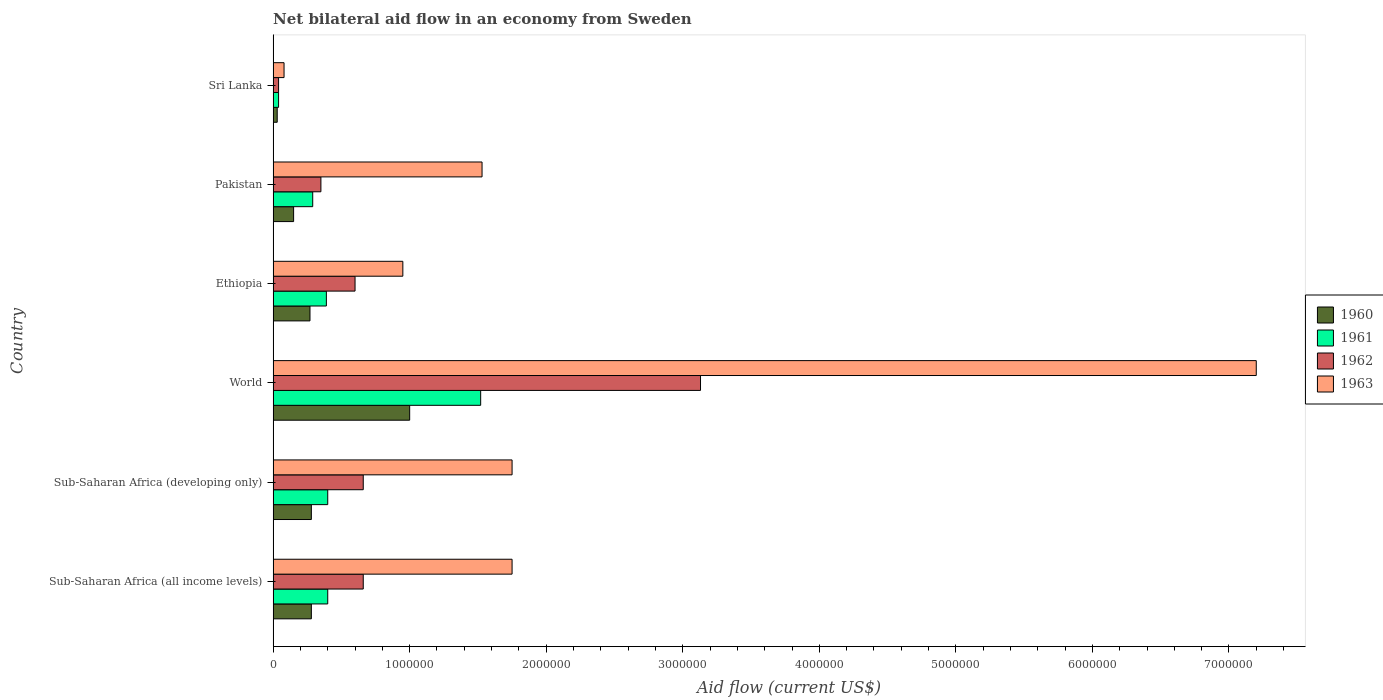Are the number of bars on each tick of the Y-axis equal?
Make the answer very short. Yes. In how many cases, is the number of bars for a given country not equal to the number of legend labels?
Keep it short and to the point. 0. What is the net bilateral aid flow in 1963 in Sub-Saharan Africa (developing only)?
Provide a succinct answer. 1.75e+06. Across all countries, what is the maximum net bilateral aid flow in 1961?
Ensure brevity in your answer.  1.52e+06. Across all countries, what is the minimum net bilateral aid flow in 1963?
Make the answer very short. 8.00e+04. In which country was the net bilateral aid flow in 1963 maximum?
Offer a very short reply. World. In which country was the net bilateral aid flow in 1961 minimum?
Provide a succinct answer. Sri Lanka. What is the total net bilateral aid flow in 1960 in the graph?
Your answer should be compact. 2.01e+06. What is the difference between the net bilateral aid flow in 1963 in Ethiopia and that in Pakistan?
Provide a short and direct response. -5.80e+05. What is the average net bilateral aid flow in 1961 per country?
Your answer should be very brief. 5.07e+05. What is the ratio of the net bilateral aid flow in 1961 in Pakistan to that in Sub-Saharan Africa (developing only)?
Give a very brief answer. 0.72. Is the net bilateral aid flow in 1961 in Sri Lanka less than that in World?
Your response must be concise. Yes. What is the difference between the highest and the second highest net bilateral aid flow in 1960?
Your answer should be very brief. 7.20e+05. What is the difference between the highest and the lowest net bilateral aid flow in 1963?
Your answer should be compact. 7.12e+06. In how many countries, is the net bilateral aid flow in 1962 greater than the average net bilateral aid flow in 1962 taken over all countries?
Provide a short and direct response. 1. Is the sum of the net bilateral aid flow in 1960 in Sub-Saharan Africa (all income levels) and World greater than the maximum net bilateral aid flow in 1961 across all countries?
Provide a succinct answer. No. What does the 1st bar from the bottom in Sub-Saharan Africa (developing only) represents?
Give a very brief answer. 1960. Is it the case that in every country, the sum of the net bilateral aid flow in 1961 and net bilateral aid flow in 1960 is greater than the net bilateral aid flow in 1963?
Provide a succinct answer. No. How many bars are there?
Offer a very short reply. 24. What is the difference between two consecutive major ticks on the X-axis?
Offer a terse response. 1.00e+06. Does the graph contain any zero values?
Make the answer very short. No. How are the legend labels stacked?
Your response must be concise. Vertical. What is the title of the graph?
Give a very brief answer. Net bilateral aid flow in an economy from Sweden. Does "1975" appear as one of the legend labels in the graph?
Keep it short and to the point. No. What is the label or title of the Y-axis?
Your answer should be compact. Country. What is the Aid flow (current US$) of 1962 in Sub-Saharan Africa (all income levels)?
Your answer should be very brief. 6.60e+05. What is the Aid flow (current US$) of 1963 in Sub-Saharan Africa (all income levels)?
Offer a terse response. 1.75e+06. What is the Aid flow (current US$) of 1961 in Sub-Saharan Africa (developing only)?
Provide a succinct answer. 4.00e+05. What is the Aid flow (current US$) of 1962 in Sub-Saharan Africa (developing only)?
Make the answer very short. 6.60e+05. What is the Aid flow (current US$) of 1963 in Sub-Saharan Africa (developing only)?
Your answer should be compact. 1.75e+06. What is the Aid flow (current US$) in 1961 in World?
Offer a very short reply. 1.52e+06. What is the Aid flow (current US$) of 1962 in World?
Your answer should be very brief. 3.13e+06. What is the Aid flow (current US$) of 1963 in World?
Give a very brief answer. 7.20e+06. What is the Aid flow (current US$) in 1960 in Ethiopia?
Your response must be concise. 2.70e+05. What is the Aid flow (current US$) in 1963 in Ethiopia?
Offer a very short reply. 9.50e+05. What is the Aid flow (current US$) of 1962 in Pakistan?
Your answer should be very brief. 3.50e+05. What is the Aid flow (current US$) in 1963 in Pakistan?
Ensure brevity in your answer.  1.53e+06. What is the Aid flow (current US$) of 1961 in Sri Lanka?
Ensure brevity in your answer.  4.00e+04. What is the Aid flow (current US$) in 1962 in Sri Lanka?
Give a very brief answer. 4.00e+04. What is the Aid flow (current US$) of 1963 in Sri Lanka?
Your response must be concise. 8.00e+04. Across all countries, what is the maximum Aid flow (current US$) of 1960?
Ensure brevity in your answer.  1.00e+06. Across all countries, what is the maximum Aid flow (current US$) in 1961?
Keep it short and to the point. 1.52e+06. Across all countries, what is the maximum Aid flow (current US$) of 1962?
Offer a very short reply. 3.13e+06. Across all countries, what is the maximum Aid flow (current US$) of 1963?
Provide a succinct answer. 7.20e+06. Across all countries, what is the minimum Aid flow (current US$) of 1962?
Provide a succinct answer. 4.00e+04. Across all countries, what is the minimum Aid flow (current US$) of 1963?
Keep it short and to the point. 8.00e+04. What is the total Aid flow (current US$) of 1960 in the graph?
Offer a very short reply. 2.01e+06. What is the total Aid flow (current US$) in 1961 in the graph?
Give a very brief answer. 3.04e+06. What is the total Aid flow (current US$) of 1962 in the graph?
Give a very brief answer. 5.44e+06. What is the total Aid flow (current US$) in 1963 in the graph?
Provide a short and direct response. 1.33e+07. What is the difference between the Aid flow (current US$) of 1962 in Sub-Saharan Africa (all income levels) and that in Sub-Saharan Africa (developing only)?
Offer a terse response. 0. What is the difference between the Aid flow (current US$) in 1963 in Sub-Saharan Africa (all income levels) and that in Sub-Saharan Africa (developing only)?
Your response must be concise. 0. What is the difference between the Aid flow (current US$) in 1960 in Sub-Saharan Africa (all income levels) and that in World?
Offer a terse response. -7.20e+05. What is the difference between the Aid flow (current US$) in 1961 in Sub-Saharan Africa (all income levels) and that in World?
Your response must be concise. -1.12e+06. What is the difference between the Aid flow (current US$) in 1962 in Sub-Saharan Africa (all income levels) and that in World?
Make the answer very short. -2.47e+06. What is the difference between the Aid flow (current US$) in 1963 in Sub-Saharan Africa (all income levels) and that in World?
Keep it short and to the point. -5.45e+06. What is the difference between the Aid flow (current US$) in 1962 in Sub-Saharan Africa (all income levels) and that in Ethiopia?
Make the answer very short. 6.00e+04. What is the difference between the Aid flow (current US$) of 1963 in Sub-Saharan Africa (all income levels) and that in Ethiopia?
Your answer should be compact. 8.00e+05. What is the difference between the Aid flow (current US$) in 1960 in Sub-Saharan Africa (all income levels) and that in Sri Lanka?
Your answer should be compact. 2.50e+05. What is the difference between the Aid flow (current US$) in 1962 in Sub-Saharan Africa (all income levels) and that in Sri Lanka?
Your response must be concise. 6.20e+05. What is the difference between the Aid flow (current US$) of 1963 in Sub-Saharan Africa (all income levels) and that in Sri Lanka?
Give a very brief answer. 1.67e+06. What is the difference between the Aid flow (current US$) in 1960 in Sub-Saharan Africa (developing only) and that in World?
Your answer should be very brief. -7.20e+05. What is the difference between the Aid flow (current US$) in 1961 in Sub-Saharan Africa (developing only) and that in World?
Ensure brevity in your answer.  -1.12e+06. What is the difference between the Aid flow (current US$) of 1962 in Sub-Saharan Africa (developing only) and that in World?
Offer a very short reply. -2.47e+06. What is the difference between the Aid flow (current US$) in 1963 in Sub-Saharan Africa (developing only) and that in World?
Your answer should be compact. -5.45e+06. What is the difference between the Aid flow (current US$) of 1961 in Sub-Saharan Africa (developing only) and that in Ethiopia?
Ensure brevity in your answer.  10000. What is the difference between the Aid flow (current US$) of 1963 in Sub-Saharan Africa (developing only) and that in Ethiopia?
Offer a terse response. 8.00e+05. What is the difference between the Aid flow (current US$) in 1960 in Sub-Saharan Africa (developing only) and that in Pakistan?
Keep it short and to the point. 1.30e+05. What is the difference between the Aid flow (current US$) in 1961 in Sub-Saharan Africa (developing only) and that in Pakistan?
Give a very brief answer. 1.10e+05. What is the difference between the Aid flow (current US$) of 1963 in Sub-Saharan Africa (developing only) and that in Pakistan?
Your response must be concise. 2.20e+05. What is the difference between the Aid flow (current US$) of 1961 in Sub-Saharan Africa (developing only) and that in Sri Lanka?
Offer a terse response. 3.60e+05. What is the difference between the Aid flow (current US$) of 1962 in Sub-Saharan Africa (developing only) and that in Sri Lanka?
Your answer should be compact. 6.20e+05. What is the difference between the Aid flow (current US$) in 1963 in Sub-Saharan Africa (developing only) and that in Sri Lanka?
Keep it short and to the point. 1.67e+06. What is the difference between the Aid flow (current US$) in 1960 in World and that in Ethiopia?
Provide a short and direct response. 7.30e+05. What is the difference between the Aid flow (current US$) in 1961 in World and that in Ethiopia?
Provide a short and direct response. 1.13e+06. What is the difference between the Aid flow (current US$) in 1962 in World and that in Ethiopia?
Your answer should be compact. 2.53e+06. What is the difference between the Aid flow (current US$) in 1963 in World and that in Ethiopia?
Give a very brief answer. 6.25e+06. What is the difference between the Aid flow (current US$) of 1960 in World and that in Pakistan?
Your response must be concise. 8.50e+05. What is the difference between the Aid flow (current US$) of 1961 in World and that in Pakistan?
Your answer should be very brief. 1.23e+06. What is the difference between the Aid flow (current US$) in 1962 in World and that in Pakistan?
Keep it short and to the point. 2.78e+06. What is the difference between the Aid flow (current US$) in 1963 in World and that in Pakistan?
Make the answer very short. 5.67e+06. What is the difference between the Aid flow (current US$) of 1960 in World and that in Sri Lanka?
Offer a very short reply. 9.70e+05. What is the difference between the Aid flow (current US$) of 1961 in World and that in Sri Lanka?
Offer a terse response. 1.48e+06. What is the difference between the Aid flow (current US$) in 1962 in World and that in Sri Lanka?
Give a very brief answer. 3.09e+06. What is the difference between the Aid flow (current US$) in 1963 in World and that in Sri Lanka?
Keep it short and to the point. 7.12e+06. What is the difference between the Aid flow (current US$) of 1960 in Ethiopia and that in Pakistan?
Your answer should be very brief. 1.20e+05. What is the difference between the Aid flow (current US$) in 1961 in Ethiopia and that in Pakistan?
Offer a terse response. 1.00e+05. What is the difference between the Aid flow (current US$) in 1962 in Ethiopia and that in Pakistan?
Ensure brevity in your answer.  2.50e+05. What is the difference between the Aid flow (current US$) in 1963 in Ethiopia and that in Pakistan?
Offer a terse response. -5.80e+05. What is the difference between the Aid flow (current US$) in 1960 in Ethiopia and that in Sri Lanka?
Offer a very short reply. 2.40e+05. What is the difference between the Aid flow (current US$) of 1962 in Ethiopia and that in Sri Lanka?
Your answer should be compact. 5.60e+05. What is the difference between the Aid flow (current US$) in 1963 in Ethiopia and that in Sri Lanka?
Offer a very short reply. 8.70e+05. What is the difference between the Aid flow (current US$) in 1960 in Pakistan and that in Sri Lanka?
Give a very brief answer. 1.20e+05. What is the difference between the Aid flow (current US$) in 1963 in Pakistan and that in Sri Lanka?
Your response must be concise. 1.45e+06. What is the difference between the Aid flow (current US$) in 1960 in Sub-Saharan Africa (all income levels) and the Aid flow (current US$) in 1961 in Sub-Saharan Africa (developing only)?
Offer a very short reply. -1.20e+05. What is the difference between the Aid flow (current US$) in 1960 in Sub-Saharan Africa (all income levels) and the Aid flow (current US$) in 1962 in Sub-Saharan Africa (developing only)?
Your answer should be very brief. -3.80e+05. What is the difference between the Aid flow (current US$) in 1960 in Sub-Saharan Africa (all income levels) and the Aid flow (current US$) in 1963 in Sub-Saharan Africa (developing only)?
Make the answer very short. -1.47e+06. What is the difference between the Aid flow (current US$) in 1961 in Sub-Saharan Africa (all income levels) and the Aid flow (current US$) in 1962 in Sub-Saharan Africa (developing only)?
Your answer should be very brief. -2.60e+05. What is the difference between the Aid flow (current US$) in 1961 in Sub-Saharan Africa (all income levels) and the Aid flow (current US$) in 1963 in Sub-Saharan Africa (developing only)?
Your answer should be very brief. -1.35e+06. What is the difference between the Aid flow (current US$) of 1962 in Sub-Saharan Africa (all income levels) and the Aid flow (current US$) of 1963 in Sub-Saharan Africa (developing only)?
Offer a very short reply. -1.09e+06. What is the difference between the Aid flow (current US$) of 1960 in Sub-Saharan Africa (all income levels) and the Aid flow (current US$) of 1961 in World?
Ensure brevity in your answer.  -1.24e+06. What is the difference between the Aid flow (current US$) in 1960 in Sub-Saharan Africa (all income levels) and the Aid flow (current US$) in 1962 in World?
Your answer should be very brief. -2.85e+06. What is the difference between the Aid flow (current US$) in 1960 in Sub-Saharan Africa (all income levels) and the Aid flow (current US$) in 1963 in World?
Keep it short and to the point. -6.92e+06. What is the difference between the Aid flow (current US$) in 1961 in Sub-Saharan Africa (all income levels) and the Aid flow (current US$) in 1962 in World?
Your answer should be very brief. -2.73e+06. What is the difference between the Aid flow (current US$) of 1961 in Sub-Saharan Africa (all income levels) and the Aid flow (current US$) of 1963 in World?
Ensure brevity in your answer.  -6.80e+06. What is the difference between the Aid flow (current US$) of 1962 in Sub-Saharan Africa (all income levels) and the Aid flow (current US$) of 1963 in World?
Offer a very short reply. -6.54e+06. What is the difference between the Aid flow (current US$) in 1960 in Sub-Saharan Africa (all income levels) and the Aid flow (current US$) in 1962 in Ethiopia?
Your response must be concise. -3.20e+05. What is the difference between the Aid flow (current US$) in 1960 in Sub-Saharan Africa (all income levels) and the Aid flow (current US$) in 1963 in Ethiopia?
Make the answer very short. -6.70e+05. What is the difference between the Aid flow (current US$) of 1961 in Sub-Saharan Africa (all income levels) and the Aid flow (current US$) of 1963 in Ethiopia?
Offer a very short reply. -5.50e+05. What is the difference between the Aid flow (current US$) of 1960 in Sub-Saharan Africa (all income levels) and the Aid flow (current US$) of 1961 in Pakistan?
Provide a short and direct response. -10000. What is the difference between the Aid flow (current US$) in 1960 in Sub-Saharan Africa (all income levels) and the Aid flow (current US$) in 1962 in Pakistan?
Your response must be concise. -7.00e+04. What is the difference between the Aid flow (current US$) in 1960 in Sub-Saharan Africa (all income levels) and the Aid flow (current US$) in 1963 in Pakistan?
Make the answer very short. -1.25e+06. What is the difference between the Aid flow (current US$) of 1961 in Sub-Saharan Africa (all income levels) and the Aid flow (current US$) of 1962 in Pakistan?
Offer a terse response. 5.00e+04. What is the difference between the Aid flow (current US$) in 1961 in Sub-Saharan Africa (all income levels) and the Aid flow (current US$) in 1963 in Pakistan?
Your response must be concise. -1.13e+06. What is the difference between the Aid flow (current US$) in 1962 in Sub-Saharan Africa (all income levels) and the Aid flow (current US$) in 1963 in Pakistan?
Offer a terse response. -8.70e+05. What is the difference between the Aid flow (current US$) in 1960 in Sub-Saharan Africa (all income levels) and the Aid flow (current US$) in 1962 in Sri Lanka?
Make the answer very short. 2.40e+05. What is the difference between the Aid flow (current US$) in 1961 in Sub-Saharan Africa (all income levels) and the Aid flow (current US$) in 1962 in Sri Lanka?
Offer a terse response. 3.60e+05. What is the difference between the Aid flow (current US$) in 1962 in Sub-Saharan Africa (all income levels) and the Aid flow (current US$) in 1963 in Sri Lanka?
Offer a very short reply. 5.80e+05. What is the difference between the Aid flow (current US$) in 1960 in Sub-Saharan Africa (developing only) and the Aid flow (current US$) in 1961 in World?
Your answer should be very brief. -1.24e+06. What is the difference between the Aid flow (current US$) in 1960 in Sub-Saharan Africa (developing only) and the Aid flow (current US$) in 1962 in World?
Provide a short and direct response. -2.85e+06. What is the difference between the Aid flow (current US$) of 1960 in Sub-Saharan Africa (developing only) and the Aid flow (current US$) of 1963 in World?
Your answer should be compact. -6.92e+06. What is the difference between the Aid flow (current US$) of 1961 in Sub-Saharan Africa (developing only) and the Aid flow (current US$) of 1962 in World?
Your response must be concise. -2.73e+06. What is the difference between the Aid flow (current US$) in 1961 in Sub-Saharan Africa (developing only) and the Aid flow (current US$) in 1963 in World?
Provide a short and direct response. -6.80e+06. What is the difference between the Aid flow (current US$) in 1962 in Sub-Saharan Africa (developing only) and the Aid flow (current US$) in 1963 in World?
Provide a short and direct response. -6.54e+06. What is the difference between the Aid flow (current US$) in 1960 in Sub-Saharan Africa (developing only) and the Aid flow (current US$) in 1961 in Ethiopia?
Your response must be concise. -1.10e+05. What is the difference between the Aid flow (current US$) in 1960 in Sub-Saharan Africa (developing only) and the Aid flow (current US$) in 1962 in Ethiopia?
Provide a short and direct response. -3.20e+05. What is the difference between the Aid flow (current US$) of 1960 in Sub-Saharan Africa (developing only) and the Aid flow (current US$) of 1963 in Ethiopia?
Provide a succinct answer. -6.70e+05. What is the difference between the Aid flow (current US$) of 1961 in Sub-Saharan Africa (developing only) and the Aid flow (current US$) of 1962 in Ethiopia?
Provide a succinct answer. -2.00e+05. What is the difference between the Aid flow (current US$) of 1961 in Sub-Saharan Africa (developing only) and the Aid flow (current US$) of 1963 in Ethiopia?
Offer a very short reply. -5.50e+05. What is the difference between the Aid flow (current US$) of 1962 in Sub-Saharan Africa (developing only) and the Aid flow (current US$) of 1963 in Ethiopia?
Your answer should be compact. -2.90e+05. What is the difference between the Aid flow (current US$) in 1960 in Sub-Saharan Africa (developing only) and the Aid flow (current US$) in 1963 in Pakistan?
Your answer should be very brief. -1.25e+06. What is the difference between the Aid flow (current US$) of 1961 in Sub-Saharan Africa (developing only) and the Aid flow (current US$) of 1963 in Pakistan?
Make the answer very short. -1.13e+06. What is the difference between the Aid flow (current US$) of 1962 in Sub-Saharan Africa (developing only) and the Aid flow (current US$) of 1963 in Pakistan?
Make the answer very short. -8.70e+05. What is the difference between the Aid flow (current US$) of 1961 in Sub-Saharan Africa (developing only) and the Aid flow (current US$) of 1962 in Sri Lanka?
Give a very brief answer. 3.60e+05. What is the difference between the Aid flow (current US$) of 1962 in Sub-Saharan Africa (developing only) and the Aid flow (current US$) of 1963 in Sri Lanka?
Your answer should be compact. 5.80e+05. What is the difference between the Aid flow (current US$) in 1960 in World and the Aid flow (current US$) in 1962 in Ethiopia?
Ensure brevity in your answer.  4.00e+05. What is the difference between the Aid flow (current US$) of 1961 in World and the Aid flow (current US$) of 1962 in Ethiopia?
Your answer should be compact. 9.20e+05. What is the difference between the Aid flow (current US$) in 1961 in World and the Aid flow (current US$) in 1963 in Ethiopia?
Your answer should be very brief. 5.70e+05. What is the difference between the Aid flow (current US$) in 1962 in World and the Aid flow (current US$) in 1963 in Ethiopia?
Your response must be concise. 2.18e+06. What is the difference between the Aid flow (current US$) of 1960 in World and the Aid flow (current US$) of 1961 in Pakistan?
Provide a short and direct response. 7.10e+05. What is the difference between the Aid flow (current US$) in 1960 in World and the Aid flow (current US$) in 1962 in Pakistan?
Ensure brevity in your answer.  6.50e+05. What is the difference between the Aid flow (current US$) in 1960 in World and the Aid flow (current US$) in 1963 in Pakistan?
Give a very brief answer. -5.30e+05. What is the difference between the Aid flow (current US$) in 1961 in World and the Aid flow (current US$) in 1962 in Pakistan?
Give a very brief answer. 1.17e+06. What is the difference between the Aid flow (current US$) of 1961 in World and the Aid flow (current US$) of 1963 in Pakistan?
Your answer should be compact. -10000. What is the difference between the Aid flow (current US$) of 1962 in World and the Aid flow (current US$) of 1963 in Pakistan?
Offer a terse response. 1.60e+06. What is the difference between the Aid flow (current US$) of 1960 in World and the Aid flow (current US$) of 1961 in Sri Lanka?
Your response must be concise. 9.60e+05. What is the difference between the Aid flow (current US$) in 1960 in World and the Aid flow (current US$) in 1962 in Sri Lanka?
Ensure brevity in your answer.  9.60e+05. What is the difference between the Aid flow (current US$) in 1960 in World and the Aid flow (current US$) in 1963 in Sri Lanka?
Your answer should be compact. 9.20e+05. What is the difference between the Aid flow (current US$) of 1961 in World and the Aid flow (current US$) of 1962 in Sri Lanka?
Provide a succinct answer. 1.48e+06. What is the difference between the Aid flow (current US$) in 1961 in World and the Aid flow (current US$) in 1963 in Sri Lanka?
Your answer should be very brief. 1.44e+06. What is the difference between the Aid flow (current US$) in 1962 in World and the Aid flow (current US$) in 1963 in Sri Lanka?
Provide a succinct answer. 3.05e+06. What is the difference between the Aid flow (current US$) of 1960 in Ethiopia and the Aid flow (current US$) of 1961 in Pakistan?
Give a very brief answer. -2.00e+04. What is the difference between the Aid flow (current US$) in 1960 in Ethiopia and the Aid flow (current US$) in 1963 in Pakistan?
Your answer should be very brief. -1.26e+06. What is the difference between the Aid flow (current US$) of 1961 in Ethiopia and the Aid flow (current US$) of 1963 in Pakistan?
Keep it short and to the point. -1.14e+06. What is the difference between the Aid flow (current US$) in 1962 in Ethiopia and the Aid flow (current US$) in 1963 in Pakistan?
Your answer should be very brief. -9.30e+05. What is the difference between the Aid flow (current US$) in 1960 in Ethiopia and the Aid flow (current US$) in 1961 in Sri Lanka?
Your response must be concise. 2.30e+05. What is the difference between the Aid flow (current US$) of 1960 in Ethiopia and the Aid flow (current US$) of 1962 in Sri Lanka?
Offer a terse response. 2.30e+05. What is the difference between the Aid flow (current US$) of 1962 in Ethiopia and the Aid flow (current US$) of 1963 in Sri Lanka?
Provide a short and direct response. 5.20e+05. What is the difference between the Aid flow (current US$) in 1960 in Pakistan and the Aid flow (current US$) in 1963 in Sri Lanka?
Provide a short and direct response. 7.00e+04. What is the difference between the Aid flow (current US$) of 1961 in Pakistan and the Aid flow (current US$) of 1962 in Sri Lanka?
Give a very brief answer. 2.50e+05. What is the difference between the Aid flow (current US$) of 1961 in Pakistan and the Aid flow (current US$) of 1963 in Sri Lanka?
Make the answer very short. 2.10e+05. What is the difference between the Aid flow (current US$) of 1962 in Pakistan and the Aid flow (current US$) of 1963 in Sri Lanka?
Give a very brief answer. 2.70e+05. What is the average Aid flow (current US$) of 1960 per country?
Your response must be concise. 3.35e+05. What is the average Aid flow (current US$) in 1961 per country?
Offer a terse response. 5.07e+05. What is the average Aid flow (current US$) in 1962 per country?
Give a very brief answer. 9.07e+05. What is the average Aid flow (current US$) in 1963 per country?
Ensure brevity in your answer.  2.21e+06. What is the difference between the Aid flow (current US$) in 1960 and Aid flow (current US$) in 1962 in Sub-Saharan Africa (all income levels)?
Your answer should be compact. -3.80e+05. What is the difference between the Aid flow (current US$) in 1960 and Aid flow (current US$) in 1963 in Sub-Saharan Africa (all income levels)?
Provide a succinct answer. -1.47e+06. What is the difference between the Aid flow (current US$) in 1961 and Aid flow (current US$) in 1963 in Sub-Saharan Africa (all income levels)?
Offer a terse response. -1.35e+06. What is the difference between the Aid flow (current US$) in 1962 and Aid flow (current US$) in 1963 in Sub-Saharan Africa (all income levels)?
Provide a short and direct response. -1.09e+06. What is the difference between the Aid flow (current US$) in 1960 and Aid flow (current US$) in 1961 in Sub-Saharan Africa (developing only)?
Your answer should be compact. -1.20e+05. What is the difference between the Aid flow (current US$) in 1960 and Aid flow (current US$) in 1962 in Sub-Saharan Africa (developing only)?
Your answer should be very brief. -3.80e+05. What is the difference between the Aid flow (current US$) in 1960 and Aid flow (current US$) in 1963 in Sub-Saharan Africa (developing only)?
Offer a terse response. -1.47e+06. What is the difference between the Aid flow (current US$) in 1961 and Aid flow (current US$) in 1963 in Sub-Saharan Africa (developing only)?
Your response must be concise. -1.35e+06. What is the difference between the Aid flow (current US$) in 1962 and Aid flow (current US$) in 1963 in Sub-Saharan Africa (developing only)?
Provide a short and direct response. -1.09e+06. What is the difference between the Aid flow (current US$) of 1960 and Aid flow (current US$) of 1961 in World?
Offer a very short reply. -5.20e+05. What is the difference between the Aid flow (current US$) in 1960 and Aid flow (current US$) in 1962 in World?
Make the answer very short. -2.13e+06. What is the difference between the Aid flow (current US$) of 1960 and Aid flow (current US$) of 1963 in World?
Give a very brief answer. -6.20e+06. What is the difference between the Aid flow (current US$) in 1961 and Aid flow (current US$) in 1962 in World?
Provide a succinct answer. -1.61e+06. What is the difference between the Aid flow (current US$) of 1961 and Aid flow (current US$) of 1963 in World?
Ensure brevity in your answer.  -5.68e+06. What is the difference between the Aid flow (current US$) of 1962 and Aid flow (current US$) of 1963 in World?
Ensure brevity in your answer.  -4.07e+06. What is the difference between the Aid flow (current US$) in 1960 and Aid flow (current US$) in 1961 in Ethiopia?
Your answer should be very brief. -1.20e+05. What is the difference between the Aid flow (current US$) in 1960 and Aid flow (current US$) in 1962 in Ethiopia?
Your answer should be very brief. -3.30e+05. What is the difference between the Aid flow (current US$) of 1960 and Aid flow (current US$) of 1963 in Ethiopia?
Your answer should be compact. -6.80e+05. What is the difference between the Aid flow (current US$) of 1961 and Aid flow (current US$) of 1963 in Ethiopia?
Make the answer very short. -5.60e+05. What is the difference between the Aid flow (current US$) of 1962 and Aid flow (current US$) of 1963 in Ethiopia?
Your answer should be compact. -3.50e+05. What is the difference between the Aid flow (current US$) in 1960 and Aid flow (current US$) in 1962 in Pakistan?
Give a very brief answer. -2.00e+05. What is the difference between the Aid flow (current US$) of 1960 and Aid flow (current US$) of 1963 in Pakistan?
Keep it short and to the point. -1.38e+06. What is the difference between the Aid flow (current US$) in 1961 and Aid flow (current US$) in 1963 in Pakistan?
Provide a short and direct response. -1.24e+06. What is the difference between the Aid flow (current US$) in 1962 and Aid flow (current US$) in 1963 in Pakistan?
Give a very brief answer. -1.18e+06. What is the difference between the Aid flow (current US$) of 1960 and Aid flow (current US$) of 1961 in Sri Lanka?
Offer a terse response. -10000. What is the difference between the Aid flow (current US$) of 1960 and Aid flow (current US$) of 1962 in Sri Lanka?
Offer a terse response. -10000. What is the difference between the Aid flow (current US$) in 1961 and Aid flow (current US$) in 1962 in Sri Lanka?
Offer a terse response. 0. What is the difference between the Aid flow (current US$) in 1961 and Aid flow (current US$) in 1963 in Sri Lanka?
Provide a succinct answer. -4.00e+04. What is the ratio of the Aid flow (current US$) in 1961 in Sub-Saharan Africa (all income levels) to that in Sub-Saharan Africa (developing only)?
Offer a very short reply. 1. What is the ratio of the Aid flow (current US$) in 1962 in Sub-Saharan Africa (all income levels) to that in Sub-Saharan Africa (developing only)?
Ensure brevity in your answer.  1. What is the ratio of the Aid flow (current US$) of 1963 in Sub-Saharan Africa (all income levels) to that in Sub-Saharan Africa (developing only)?
Offer a terse response. 1. What is the ratio of the Aid flow (current US$) in 1960 in Sub-Saharan Africa (all income levels) to that in World?
Offer a terse response. 0.28. What is the ratio of the Aid flow (current US$) in 1961 in Sub-Saharan Africa (all income levels) to that in World?
Make the answer very short. 0.26. What is the ratio of the Aid flow (current US$) of 1962 in Sub-Saharan Africa (all income levels) to that in World?
Provide a short and direct response. 0.21. What is the ratio of the Aid flow (current US$) of 1963 in Sub-Saharan Africa (all income levels) to that in World?
Make the answer very short. 0.24. What is the ratio of the Aid flow (current US$) in 1961 in Sub-Saharan Africa (all income levels) to that in Ethiopia?
Your answer should be very brief. 1.03. What is the ratio of the Aid flow (current US$) in 1962 in Sub-Saharan Africa (all income levels) to that in Ethiopia?
Give a very brief answer. 1.1. What is the ratio of the Aid flow (current US$) of 1963 in Sub-Saharan Africa (all income levels) to that in Ethiopia?
Your answer should be very brief. 1.84. What is the ratio of the Aid flow (current US$) of 1960 in Sub-Saharan Africa (all income levels) to that in Pakistan?
Keep it short and to the point. 1.87. What is the ratio of the Aid flow (current US$) of 1961 in Sub-Saharan Africa (all income levels) to that in Pakistan?
Keep it short and to the point. 1.38. What is the ratio of the Aid flow (current US$) in 1962 in Sub-Saharan Africa (all income levels) to that in Pakistan?
Make the answer very short. 1.89. What is the ratio of the Aid flow (current US$) in 1963 in Sub-Saharan Africa (all income levels) to that in Pakistan?
Provide a succinct answer. 1.14. What is the ratio of the Aid flow (current US$) of 1960 in Sub-Saharan Africa (all income levels) to that in Sri Lanka?
Keep it short and to the point. 9.33. What is the ratio of the Aid flow (current US$) in 1961 in Sub-Saharan Africa (all income levels) to that in Sri Lanka?
Offer a very short reply. 10. What is the ratio of the Aid flow (current US$) of 1963 in Sub-Saharan Africa (all income levels) to that in Sri Lanka?
Offer a very short reply. 21.88. What is the ratio of the Aid flow (current US$) of 1960 in Sub-Saharan Africa (developing only) to that in World?
Offer a terse response. 0.28. What is the ratio of the Aid flow (current US$) of 1961 in Sub-Saharan Africa (developing only) to that in World?
Your answer should be compact. 0.26. What is the ratio of the Aid flow (current US$) in 1962 in Sub-Saharan Africa (developing only) to that in World?
Your response must be concise. 0.21. What is the ratio of the Aid flow (current US$) of 1963 in Sub-Saharan Africa (developing only) to that in World?
Ensure brevity in your answer.  0.24. What is the ratio of the Aid flow (current US$) in 1961 in Sub-Saharan Africa (developing only) to that in Ethiopia?
Your answer should be compact. 1.03. What is the ratio of the Aid flow (current US$) in 1962 in Sub-Saharan Africa (developing only) to that in Ethiopia?
Offer a terse response. 1.1. What is the ratio of the Aid flow (current US$) in 1963 in Sub-Saharan Africa (developing only) to that in Ethiopia?
Make the answer very short. 1.84. What is the ratio of the Aid flow (current US$) of 1960 in Sub-Saharan Africa (developing only) to that in Pakistan?
Provide a short and direct response. 1.87. What is the ratio of the Aid flow (current US$) of 1961 in Sub-Saharan Africa (developing only) to that in Pakistan?
Your response must be concise. 1.38. What is the ratio of the Aid flow (current US$) in 1962 in Sub-Saharan Africa (developing only) to that in Pakistan?
Provide a short and direct response. 1.89. What is the ratio of the Aid flow (current US$) in 1963 in Sub-Saharan Africa (developing only) to that in Pakistan?
Give a very brief answer. 1.14. What is the ratio of the Aid flow (current US$) in 1960 in Sub-Saharan Africa (developing only) to that in Sri Lanka?
Your response must be concise. 9.33. What is the ratio of the Aid flow (current US$) of 1961 in Sub-Saharan Africa (developing only) to that in Sri Lanka?
Your response must be concise. 10. What is the ratio of the Aid flow (current US$) in 1962 in Sub-Saharan Africa (developing only) to that in Sri Lanka?
Your answer should be compact. 16.5. What is the ratio of the Aid flow (current US$) in 1963 in Sub-Saharan Africa (developing only) to that in Sri Lanka?
Your response must be concise. 21.88. What is the ratio of the Aid flow (current US$) of 1960 in World to that in Ethiopia?
Your answer should be very brief. 3.7. What is the ratio of the Aid flow (current US$) in 1961 in World to that in Ethiopia?
Give a very brief answer. 3.9. What is the ratio of the Aid flow (current US$) in 1962 in World to that in Ethiopia?
Offer a terse response. 5.22. What is the ratio of the Aid flow (current US$) of 1963 in World to that in Ethiopia?
Offer a very short reply. 7.58. What is the ratio of the Aid flow (current US$) in 1960 in World to that in Pakistan?
Keep it short and to the point. 6.67. What is the ratio of the Aid flow (current US$) in 1961 in World to that in Pakistan?
Keep it short and to the point. 5.24. What is the ratio of the Aid flow (current US$) in 1962 in World to that in Pakistan?
Offer a terse response. 8.94. What is the ratio of the Aid flow (current US$) of 1963 in World to that in Pakistan?
Provide a succinct answer. 4.71. What is the ratio of the Aid flow (current US$) in 1960 in World to that in Sri Lanka?
Your answer should be very brief. 33.33. What is the ratio of the Aid flow (current US$) of 1961 in World to that in Sri Lanka?
Your response must be concise. 38. What is the ratio of the Aid flow (current US$) in 1962 in World to that in Sri Lanka?
Your answer should be compact. 78.25. What is the ratio of the Aid flow (current US$) of 1963 in World to that in Sri Lanka?
Provide a short and direct response. 90. What is the ratio of the Aid flow (current US$) of 1960 in Ethiopia to that in Pakistan?
Give a very brief answer. 1.8. What is the ratio of the Aid flow (current US$) in 1961 in Ethiopia to that in Pakistan?
Keep it short and to the point. 1.34. What is the ratio of the Aid flow (current US$) of 1962 in Ethiopia to that in Pakistan?
Offer a very short reply. 1.71. What is the ratio of the Aid flow (current US$) in 1963 in Ethiopia to that in Pakistan?
Provide a short and direct response. 0.62. What is the ratio of the Aid flow (current US$) in 1961 in Ethiopia to that in Sri Lanka?
Your answer should be compact. 9.75. What is the ratio of the Aid flow (current US$) in 1962 in Ethiopia to that in Sri Lanka?
Offer a very short reply. 15. What is the ratio of the Aid flow (current US$) in 1963 in Ethiopia to that in Sri Lanka?
Your response must be concise. 11.88. What is the ratio of the Aid flow (current US$) of 1961 in Pakistan to that in Sri Lanka?
Keep it short and to the point. 7.25. What is the ratio of the Aid flow (current US$) in 1962 in Pakistan to that in Sri Lanka?
Offer a terse response. 8.75. What is the ratio of the Aid flow (current US$) in 1963 in Pakistan to that in Sri Lanka?
Make the answer very short. 19.12. What is the difference between the highest and the second highest Aid flow (current US$) in 1960?
Give a very brief answer. 7.20e+05. What is the difference between the highest and the second highest Aid flow (current US$) in 1961?
Provide a short and direct response. 1.12e+06. What is the difference between the highest and the second highest Aid flow (current US$) of 1962?
Offer a very short reply. 2.47e+06. What is the difference between the highest and the second highest Aid flow (current US$) in 1963?
Give a very brief answer. 5.45e+06. What is the difference between the highest and the lowest Aid flow (current US$) of 1960?
Make the answer very short. 9.70e+05. What is the difference between the highest and the lowest Aid flow (current US$) in 1961?
Your response must be concise. 1.48e+06. What is the difference between the highest and the lowest Aid flow (current US$) in 1962?
Offer a terse response. 3.09e+06. What is the difference between the highest and the lowest Aid flow (current US$) of 1963?
Your response must be concise. 7.12e+06. 